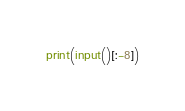Convert code to text. <code><loc_0><loc_0><loc_500><loc_500><_Python_>print(input()[:-8])
</code> 